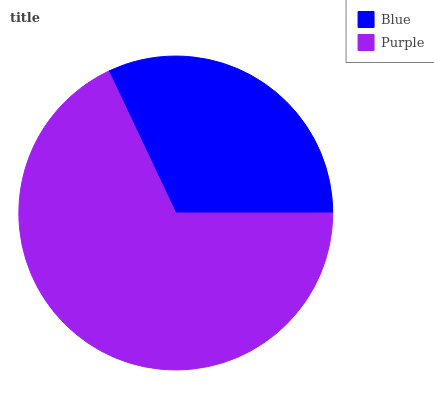Is Blue the minimum?
Answer yes or no. Yes. Is Purple the maximum?
Answer yes or no. Yes. Is Purple the minimum?
Answer yes or no. No. Is Purple greater than Blue?
Answer yes or no. Yes. Is Blue less than Purple?
Answer yes or no. Yes. Is Blue greater than Purple?
Answer yes or no. No. Is Purple less than Blue?
Answer yes or no. No. Is Purple the high median?
Answer yes or no. Yes. Is Blue the low median?
Answer yes or no. Yes. Is Blue the high median?
Answer yes or no. No. Is Purple the low median?
Answer yes or no. No. 